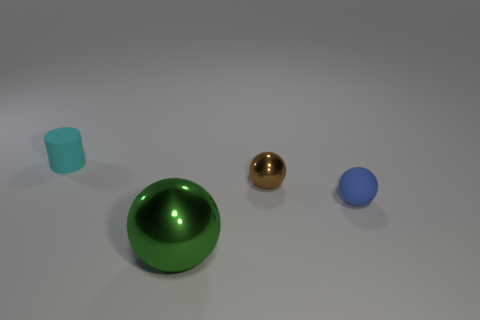Add 3 tiny blue matte objects. How many objects exist? 7 Subtract all cylinders. How many objects are left? 3 Add 4 large cyan shiny cylinders. How many large cyan shiny cylinders exist? 4 Subtract 0 gray cylinders. How many objects are left? 4 Subtract all tiny cyan matte cylinders. Subtract all big green metal objects. How many objects are left? 2 Add 3 small cyan rubber things. How many small cyan rubber things are left? 4 